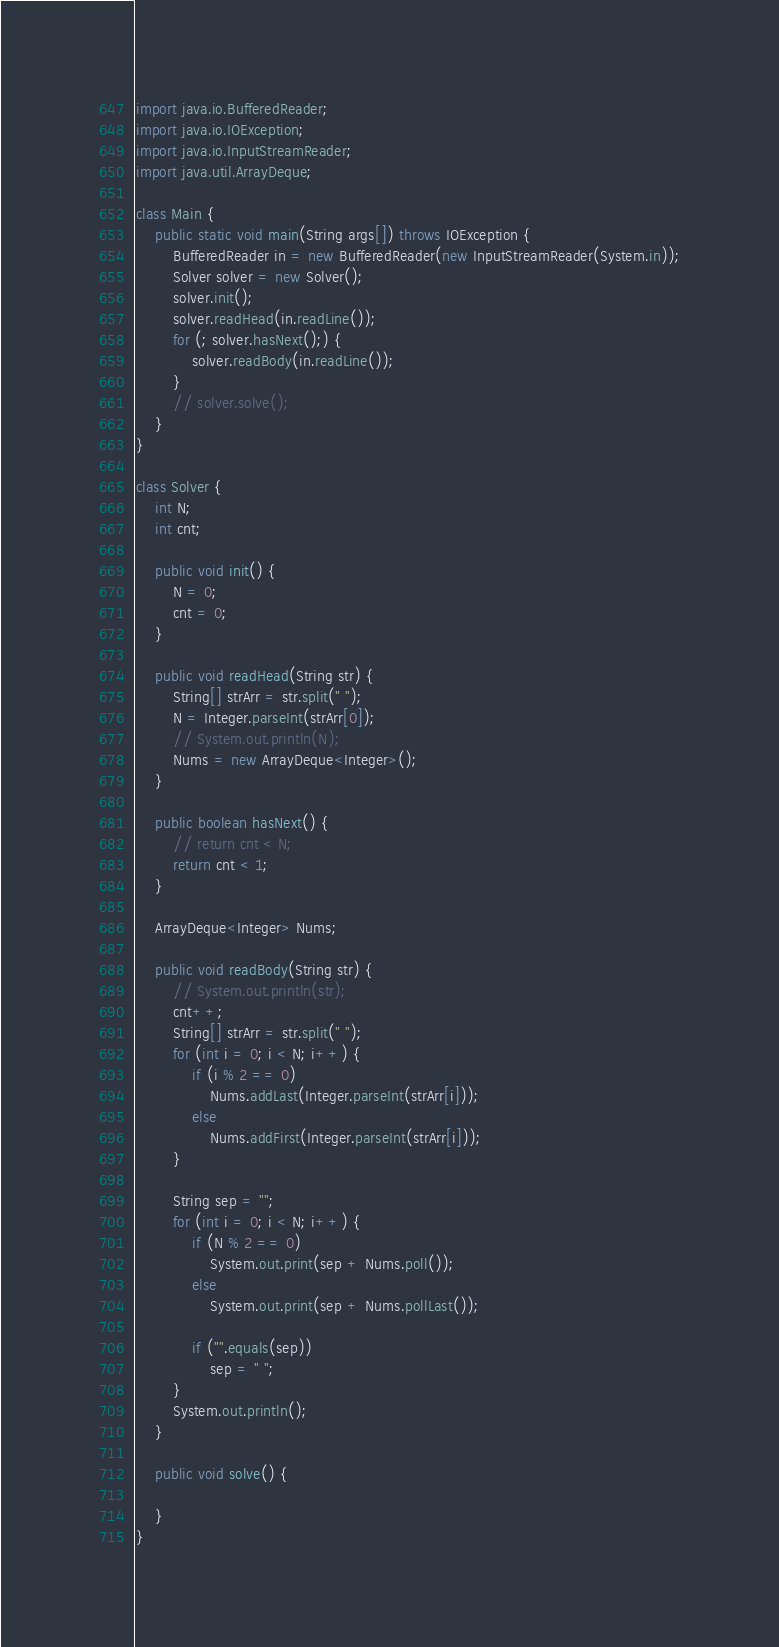<code> <loc_0><loc_0><loc_500><loc_500><_Java_>import java.io.BufferedReader;
import java.io.IOException;
import java.io.InputStreamReader;
import java.util.ArrayDeque;

class Main {
	public static void main(String args[]) throws IOException {
		BufferedReader in = new BufferedReader(new InputStreamReader(System.in));
		Solver solver = new Solver();
		solver.init();
		solver.readHead(in.readLine());
		for (; solver.hasNext();) {
			solver.readBody(in.readLine());
		}
		// solver.solve();
	}
}

class Solver {
	int N;
	int cnt;

	public void init() {
		N = 0;
		cnt = 0;
	}

	public void readHead(String str) {
		String[] strArr = str.split(" ");
		N = Integer.parseInt(strArr[0]);
		// System.out.println(N);
		Nums = new ArrayDeque<Integer>();
	}

	public boolean hasNext() {
		// return cnt < N;
		return cnt < 1;
	}

	ArrayDeque<Integer> Nums;

	public void readBody(String str) {
		// System.out.println(str);
		cnt++;
		String[] strArr = str.split(" ");
		for (int i = 0; i < N; i++) {
			if (i % 2 == 0)
				Nums.addLast(Integer.parseInt(strArr[i]));
			else
				Nums.addFirst(Integer.parseInt(strArr[i]));
		}

		String sep = "";
		for (int i = 0; i < N; i++) {
			if (N % 2 == 0)
				System.out.print(sep + Nums.poll());
			else
				System.out.print(sep + Nums.pollLast());

			if ("".equals(sep))
				sep = " ";
		}
		System.out.println();
	}

	public void solve() {

	}
}
</code> 